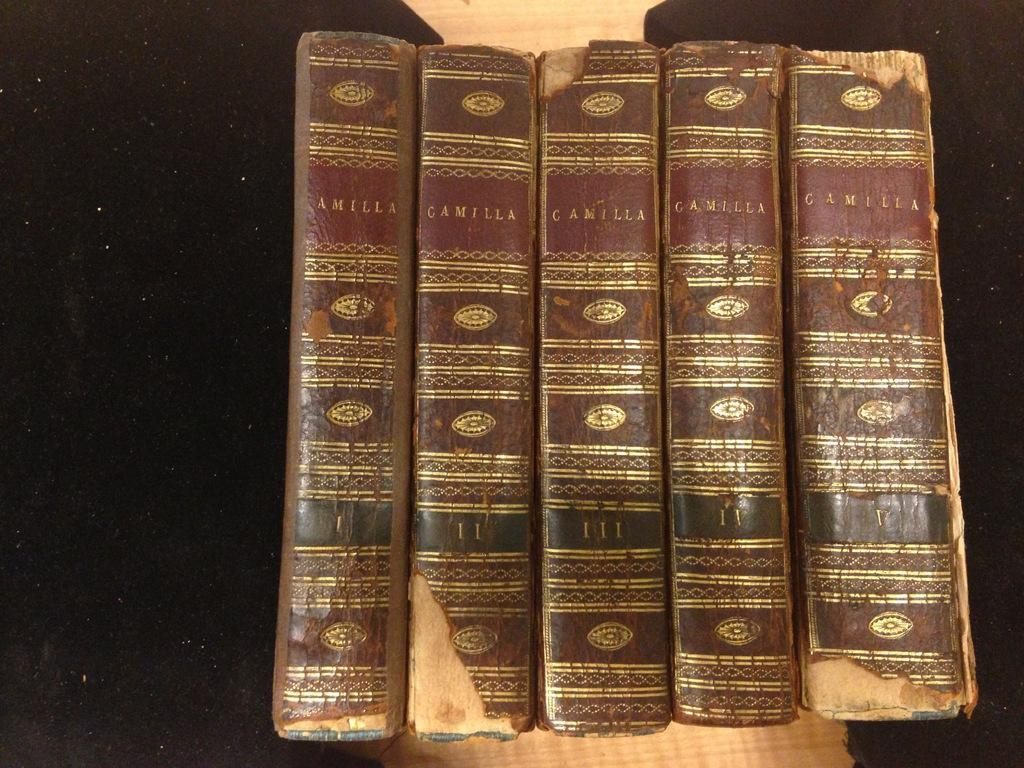Provide a one-sentence caption for the provided image. Some old books with the title Camilla on it. 